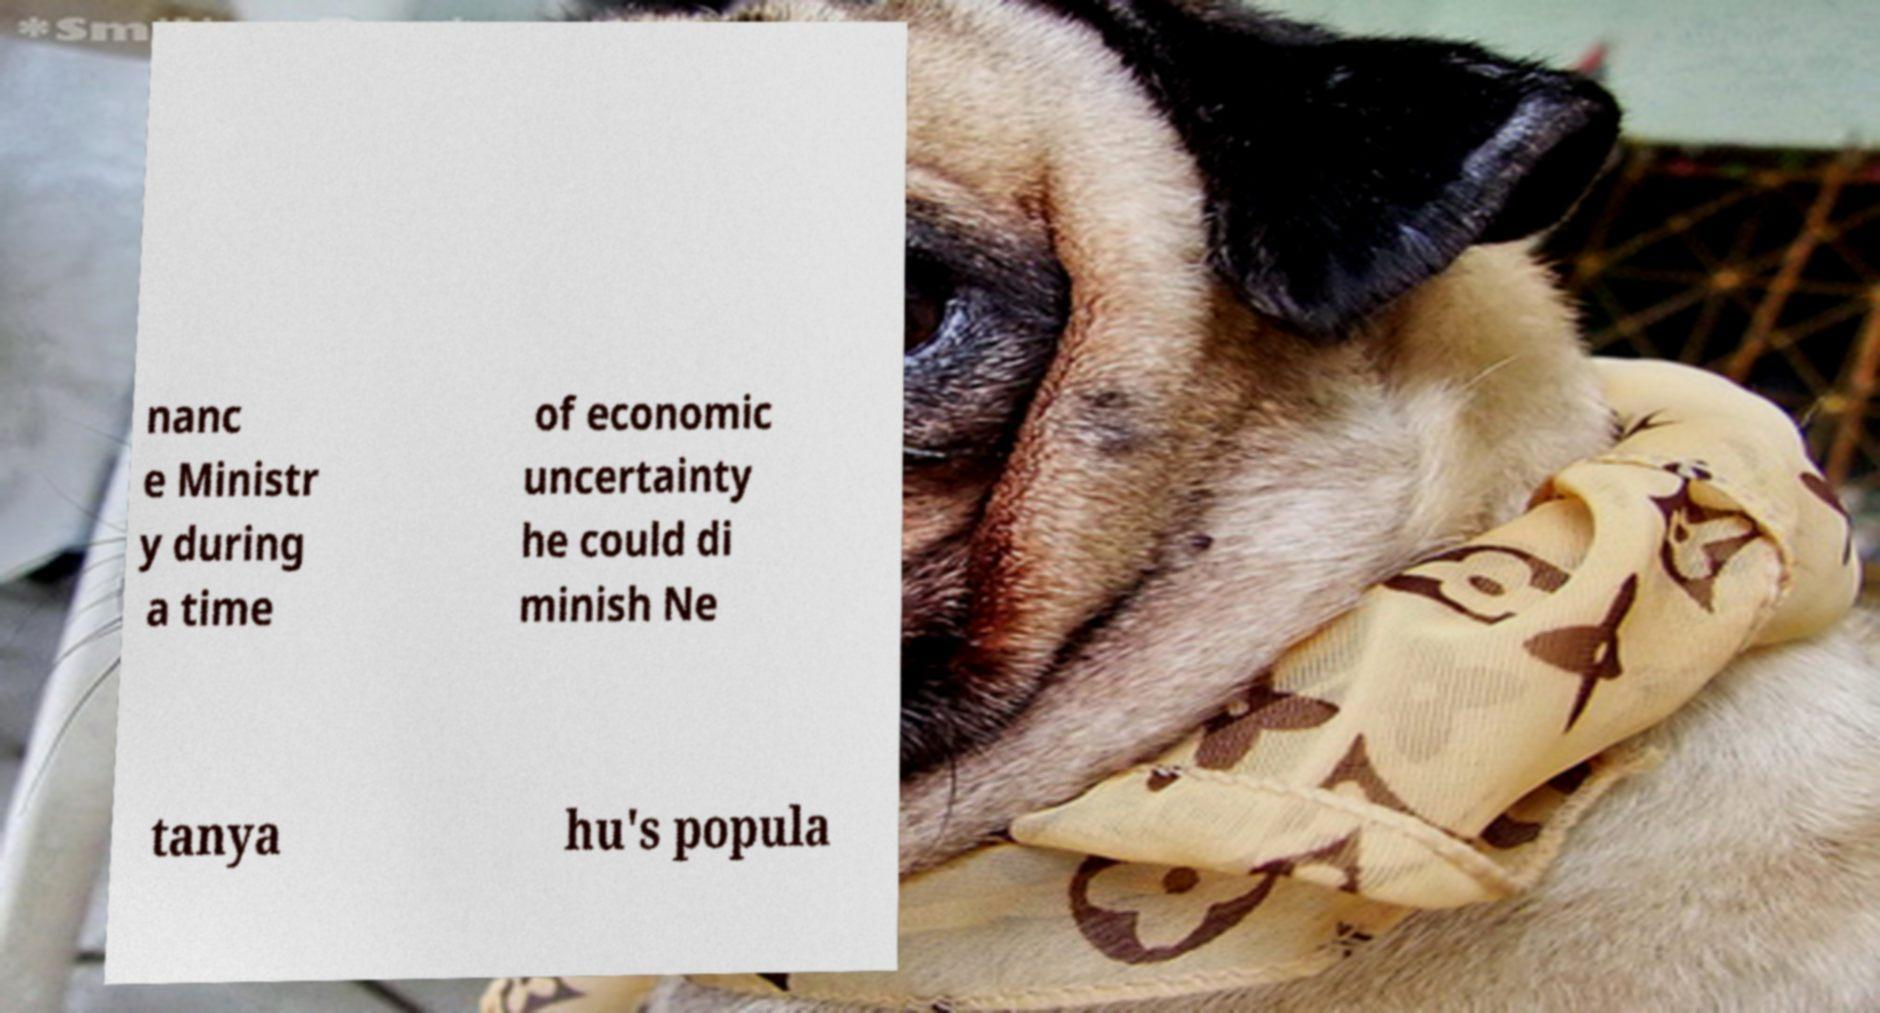Please read and relay the text visible in this image. What does it say? nanc e Ministr y during a time of economic uncertainty he could di minish Ne tanya hu's popula 